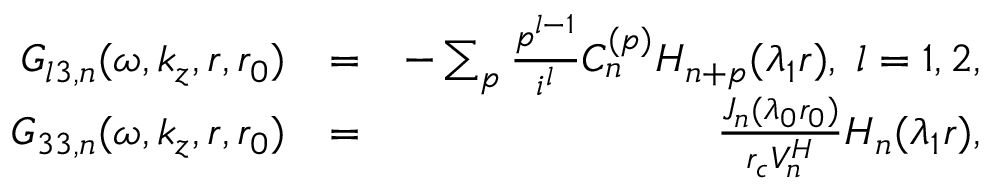<formula> <loc_0><loc_0><loc_500><loc_500>\begin{array} { r l r } { G _ { l 3 , n } ( \omega , k _ { z } , r , r _ { 0 } ) } & { = } & { - \sum _ { p } \frac { p ^ { l - 1 } } { i ^ { l } } C _ { n } ^ { ( p ) } H _ { n + p } ( \lambda _ { 1 } r ) , \, l = 1 , 2 , } \\ { G _ { 3 3 , n } ( \omega , k _ { z } , r , r _ { 0 } ) } & { = } & { \frac { J _ { n } ( \lambda _ { 0 } r _ { 0 } ) } { r _ { c } V _ { n } ^ { H } } H _ { n } ( \lambda _ { 1 } r ) , } \end{array}</formula> 